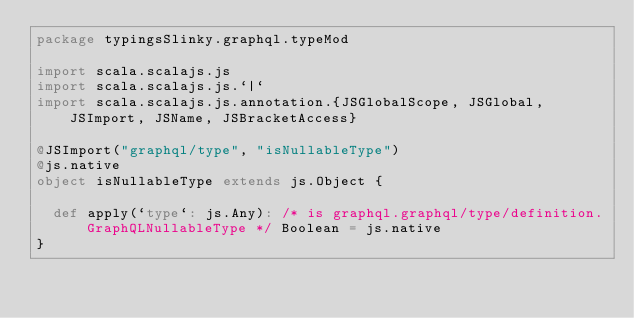Convert code to text. <code><loc_0><loc_0><loc_500><loc_500><_Scala_>package typingsSlinky.graphql.typeMod

import scala.scalajs.js
import scala.scalajs.js.`|`
import scala.scalajs.js.annotation.{JSGlobalScope, JSGlobal, JSImport, JSName, JSBracketAccess}

@JSImport("graphql/type", "isNullableType")
@js.native
object isNullableType extends js.Object {
  
  def apply(`type`: js.Any): /* is graphql.graphql/type/definition.GraphQLNullableType */ Boolean = js.native
}
</code> 